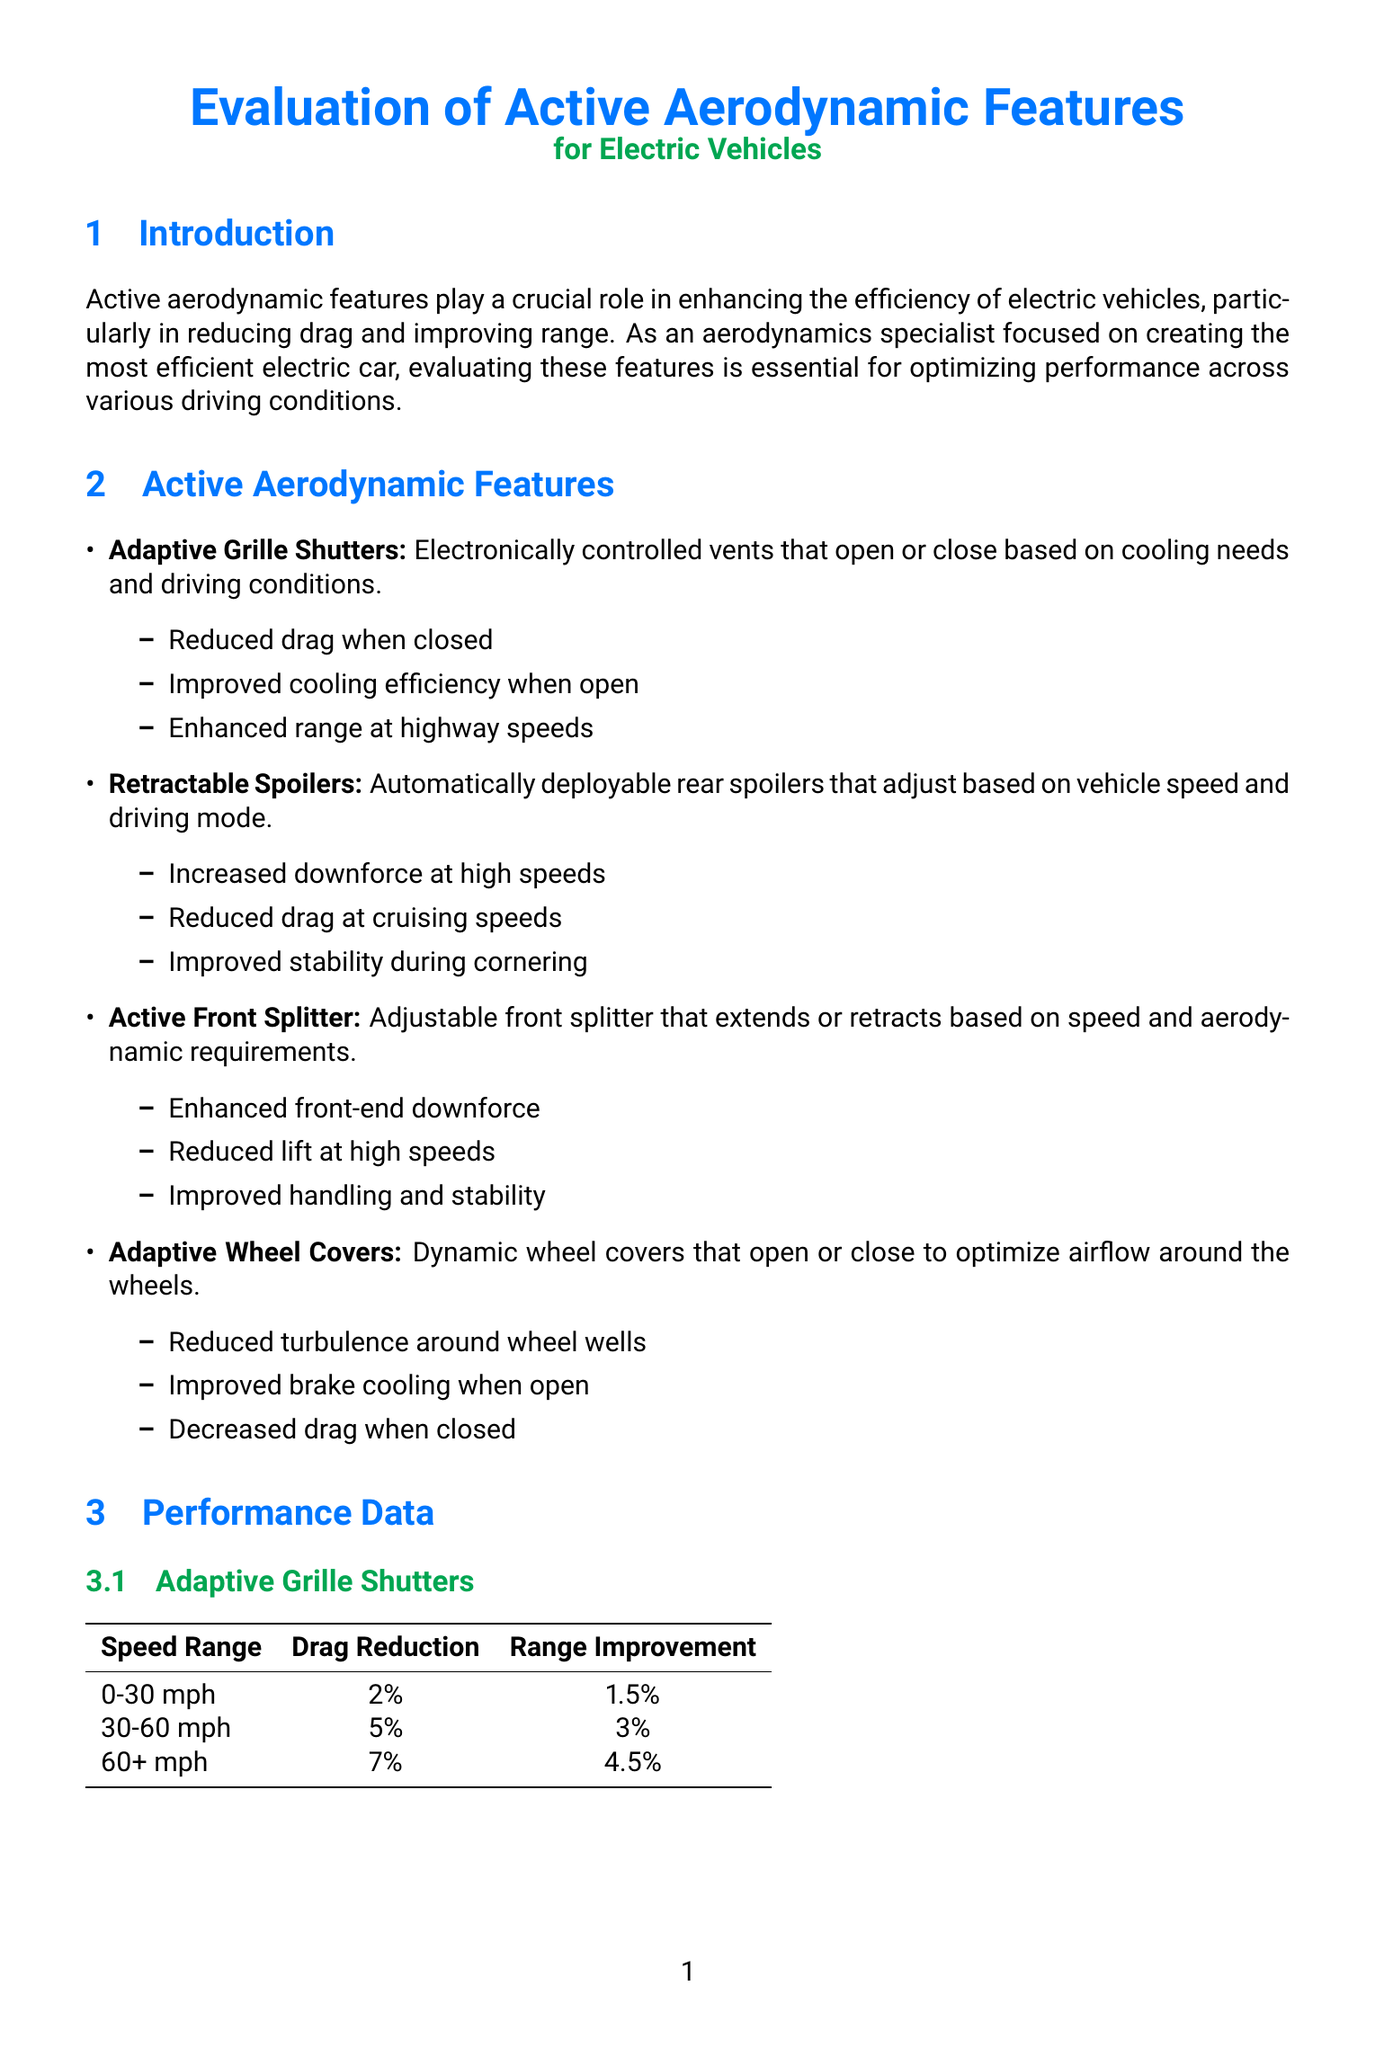What role do active aerodynamic features play in electric vehicles? Active aerodynamic features enhance efficiency by reducing drag and improving range.
Answer: Reducing drag and improving range What is the average energy efficiency gain in urban conditions? The document states the average energy efficiency gain for urban conditions is 3.5%.
Answer: 3.5% Which feature provides improved cooling efficiency when open? The document mentions that Adaptive Grille Shutters enhance cooling efficiency when open.
Answer: Adaptive Grille Shutters What is the drag reduction percentage for Adaptive Grille Shutters at 60+ mph? The document lists the drag reduction for this speed range at 7%.
Answer: 7% Which vehicle exhibited a drag coefficient of 0.208? The Tesla Model S Plaid is reported to have a drag coefficient of 0.208.
Answer: Tesla Model S Plaid What combination of features is recommended for optimal vehicle efficiency? The report recommends implementing adaptive grille shutters, retractable spoilers, and active front splitters.
Answer: Adaptive grille shutters, retractable spoilers, and active front splitters At what speed range do Retractable Spoilers increase downforce by 25%? The performance data indicates that at 75+ mph, downforce increases by 25%.
Answer: 75+ mph What are the most effective features in mixed driving conditions? For mixed conditions, the document states that Adaptive Grille Shutters and Retractable Spoilers are most effective.
Answer: Adaptive Grille Shutters and Retractable Spoilers What future consideration involves AI? The document mentions the integration of AI-driven predictive aerodynamics as a future consideration.
Answer: AI-driven predictive aerodynamics 